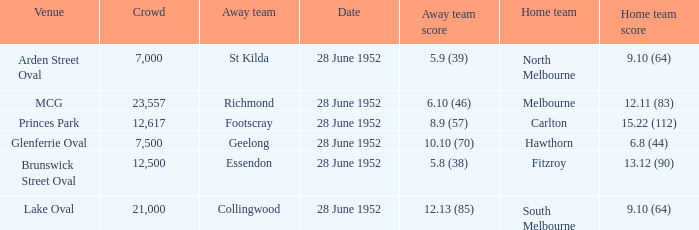Who is the away side when north melbourne is at home and has a score of 9.10 (64)? St Kilda. 